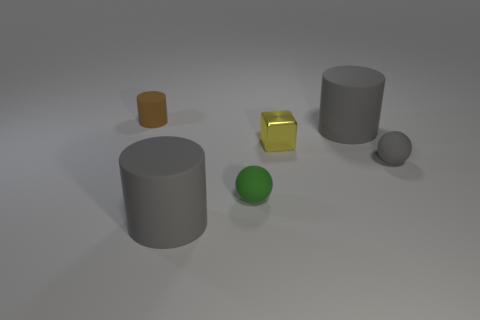Are there any yellow rubber objects that have the same size as the yellow shiny thing?
Keep it short and to the point. No. How many things are either large gray balls or small brown things?
Keep it short and to the point. 1. There is a brown thing that is to the left of the green rubber sphere; is it the same size as the gray cylinder that is behind the tiny green ball?
Provide a short and direct response. No. Is there another rubber object of the same shape as the green matte object?
Your answer should be compact. Yes. Are there fewer yellow cubes in front of the tiny green rubber ball than gray cylinders?
Offer a terse response. Yes. Does the tiny brown rubber thing have the same shape as the small green matte thing?
Offer a very short reply. No. How big is the gray rubber cylinder that is on the left side of the small yellow shiny thing?
Provide a succinct answer. Large. What size is the brown object that is the same material as the gray sphere?
Give a very brief answer. Small. Are there fewer small metallic things than big things?
Keep it short and to the point. Yes. There is a yellow block that is the same size as the brown rubber cylinder; what material is it?
Your answer should be compact. Metal. 